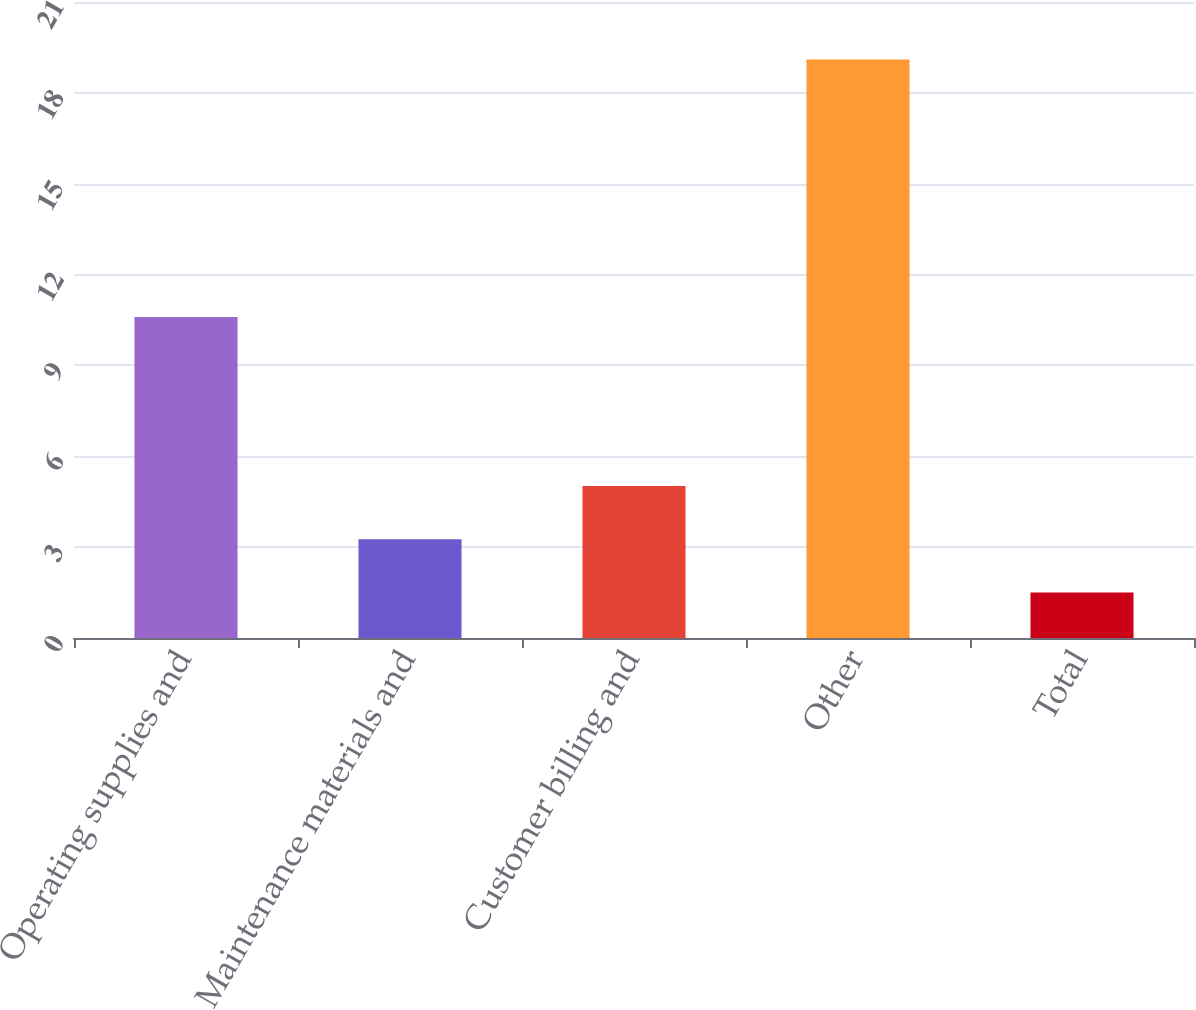Convert chart. <chart><loc_0><loc_0><loc_500><loc_500><bar_chart><fcel>Operating supplies and<fcel>Maintenance materials and<fcel>Customer billing and<fcel>Other<fcel>Total<nl><fcel>10.6<fcel>3.26<fcel>5.02<fcel>19.1<fcel>1.5<nl></chart> 